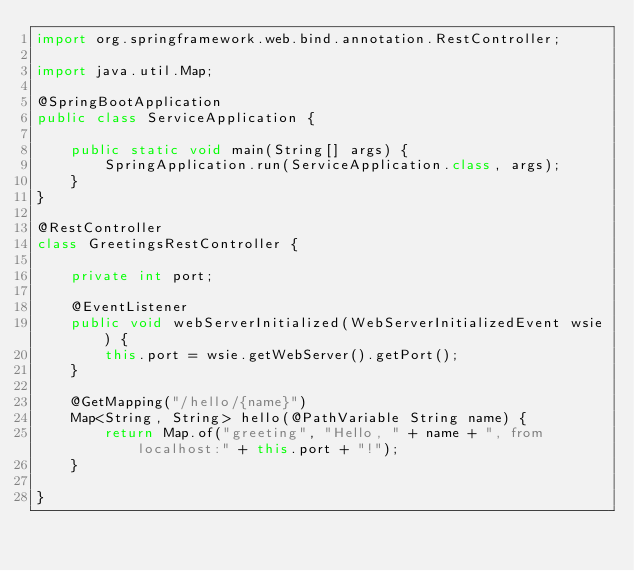<code> <loc_0><loc_0><loc_500><loc_500><_Java_>import org.springframework.web.bind.annotation.RestController;

import java.util.Map;

@SpringBootApplication
public class ServiceApplication {

    public static void main(String[] args) {
        SpringApplication.run(ServiceApplication.class, args);
    }
}

@RestController
class GreetingsRestController {

    private int port;

    @EventListener
    public void webServerInitialized(WebServerInitializedEvent wsie) {
        this.port = wsie.getWebServer().getPort();
    }

    @GetMapping("/hello/{name}")
    Map<String, String> hello(@PathVariable String name) {
        return Map.of("greeting", "Hello, " + name + ", from localhost:" + this.port + "!");
    }

}</code> 